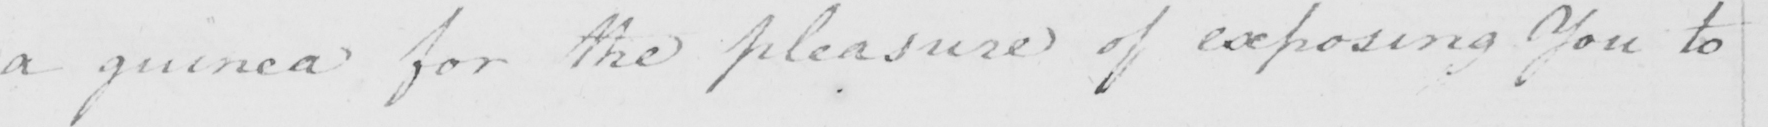What does this handwritten line say? a guinea for the pleasure of exposing You to 